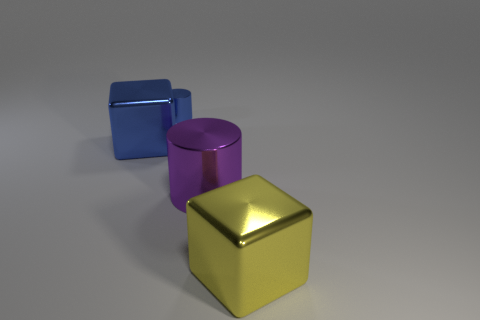The metal block that is the same color as the tiny object is what size?
Your answer should be compact. Large. There is a object that is to the left of the tiny blue shiny cylinder; is it the same shape as the purple object?
Ensure brevity in your answer.  No. Are there any other things that are made of the same material as the purple cylinder?
Provide a short and direct response. Yes. There is a purple metallic object; is it the same size as the shiny cube in front of the big blue metallic cube?
Your answer should be compact. Yes. What number of other objects are there of the same color as the small cylinder?
Ensure brevity in your answer.  1. There is a large cylinder; are there any tiny metal cylinders to the left of it?
Ensure brevity in your answer.  Yes. How many things are either big yellow metal things or big metallic cubes right of the purple metallic object?
Provide a succinct answer. 1. There is a large object on the left side of the tiny shiny cylinder; are there any blue objects that are right of it?
Your response must be concise. Yes. The object behind the cube to the left of the large block that is in front of the large blue shiny object is what shape?
Keep it short and to the point. Cylinder. What color is the large shiny object that is both in front of the large blue shiny thing and behind the big yellow metallic cube?
Provide a short and direct response. Purple. 